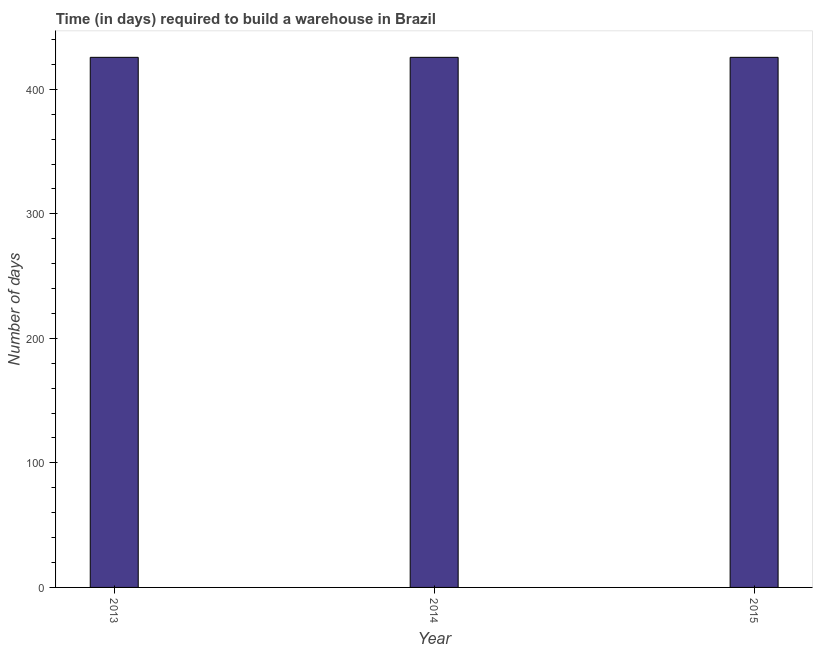Does the graph contain grids?
Your answer should be compact. No. What is the title of the graph?
Provide a succinct answer. Time (in days) required to build a warehouse in Brazil. What is the label or title of the Y-axis?
Ensure brevity in your answer.  Number of days. What is the time required to build a warehouse in 2014?
Give a very brief answer. 425.7. Across all years, what is the maximum time required to build a warehouse?
Keep it short and to the point. 425.7. Across all years, what is the minimum time required to build a warehouse?
Provide a short and direct response. 425.7. What is the sum of the time required to build a warehouse?
Provide a succinct answer. 1277.1. What is the difference between the time required to build a warehouse in 2013 and 2015?
Make the answer very short. 0. What is the average time required to build a warehouse per year?
Your answer should be compact. 425.7. What is the median time required to build a warehouse?
Ensure brevity in your answer.  425.7. In how many years, is the time required to build a warehouse greater than 400 days?
Offer a very short reply. 3. Is the difference between the time required to build a warehouse in 2014 and 2015 greater than the difference between any two years?
Provide a succinct answer. Yes. Is the sum of the time required to build a warehouse in 2014 and 2015 greater than the maximum time required to build a warehouse across all years?
Offer a terse response. Yes. What is the difference between the highest and the lowest time required to build a warehouse?
Make the answer very short. 0. In how many years, is the time required to build a warehouse greater than the average time required to build a warehouse taken over all years?
Your response must be concise. 0. Are the values on the major ticks of Y-axis written in scientific E-notation?
Offer a very short reply. No. What is the Number of days in 2013?
Your response must be concise. 425.7. What is the Number of days of 2014?
Keep it short and to the point. 425.7. What is the Number of days in 2015?
Your response must be concise. 425.7. What is the difference between the Number of days in 2013 and 2014?
Your answer should be compact. 0. What is the ratio of the Number of days in 2013 to that in 2015?
Your answer should be very brief. 1. What is the ratio of the Number of days in 2014 to that in 2015?
Offer a terse response. 1. 